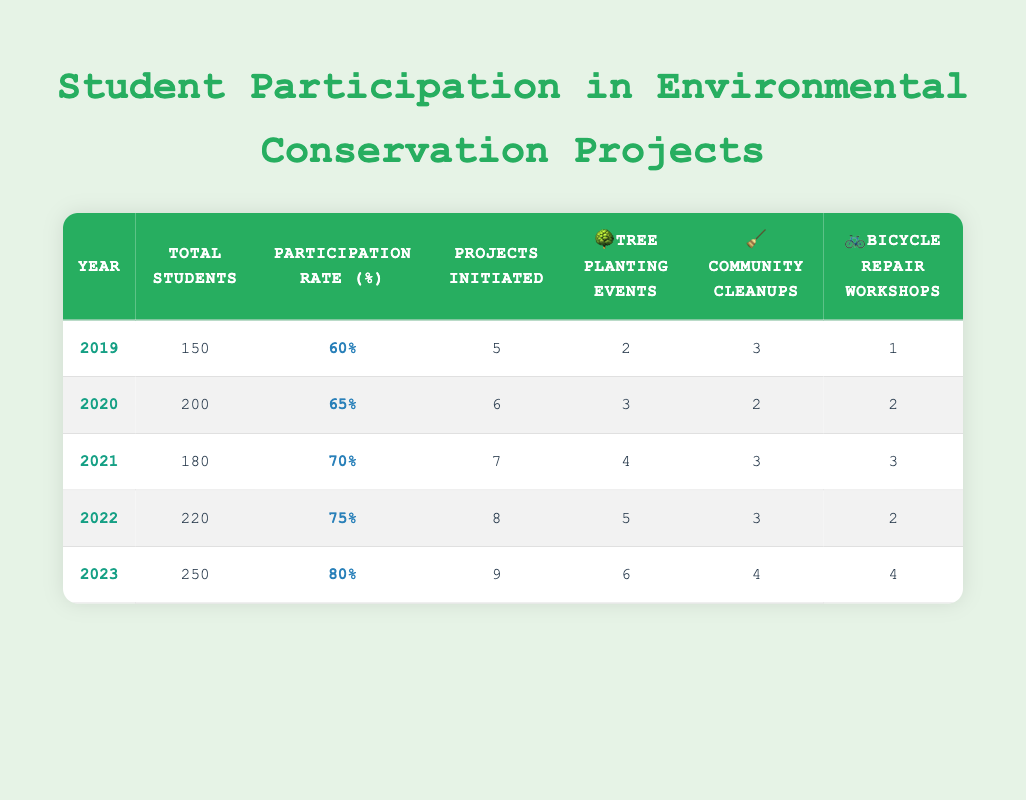What was the participation rate in 2021? From the table, the participation rate for 2021 is explicitly listed in the "Participation Rate (%)" column under the 2021 row. It reads 70%.
Answer: 70% How many tree planting events were held in 2020? The number of tree planting events for 2020 can be found directly in the corresponding row under the "Tree Planting Events" column. For the year 2020, it states 3 events.
Answer: 3 What is the total number of projects initiated from 2019 to 2023? To find the total, we sum the "Projects Initiated" from each of the relevant rows: 5 (2019) + 6 (2020) + 7 (2021) + 8 (2022) + 9 (2023) = 35.
Answer: 35 Has the total number of students increased every year from 2019 to 2023? We review the "Total Students" column for each year: 150 (2019) < 200 (2020) < 180 (2021) < 220 (2022) < 250 (2023). The total students decreased from 2019 to 2021 before resuming an increase, thus not every year saw an increase.
Answer: No What is the average participation rate over the five years? To calculate the average, we first sum the participation rates: 60 + 65 + 70 + 75 + 80 = 350. Then we divide that total by the number of years: 350 / 5 = 70.
Answer: 70 How many more bicycle repair workshops were conducted in 2023 compared to 2019? We take the values from the "Bicycle Repair Workshops" column: 4 (2023) - 1 (2019) = 3. Thus, there were 3 more workshop events in 2023 than in 2019.
Answer: 3 Did the number of community cleanups increase from 2020 to 2022? Checking the "Community Cleanups" column, the values are 2 (2020), 3 (2021), and 3 (2022). The number did increase from 2020 to 2021, but there was no increase from 2021 to 2022. Therefore, overall, the number did increase, but not consistently for each year.
Answer: No What is the total number of tree planting events conducted across all five years? We sum the "Tree Planting Events" for each year: 2 (2019) + 3 (2020) + 4 (2021) + 5 (2022) + 6 (2023) = 20. Therefore, the total across all years is 20 events.
Answer: 20 